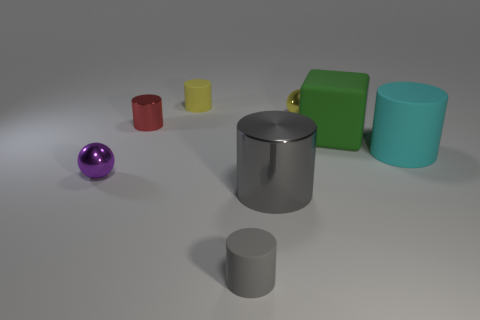Subtract all cyan cylinders. How many cylinders are left? 4 Subtract all yellow matte cylinders. How many cylinders are left? 4 Subtract 1 cylinders. How many cylinders are left? 4 Subtract all green cylinders. Subtract all blue cubes. How many cylinders are left? 5 Add 1 small gray objects. How many objects exist? 9 Subtract all balls. How many objects are left? 6 Subtract 1 yellow cylinders. How many objects are left? 7 Subtract all large cyan rubber cylinders. Subtract all gray cylinders. How many objects are left? 5 Add 8 big gray things. How many big gray things are left? 9 Add 1 small blue balls. How many small blue balls exist? 1 